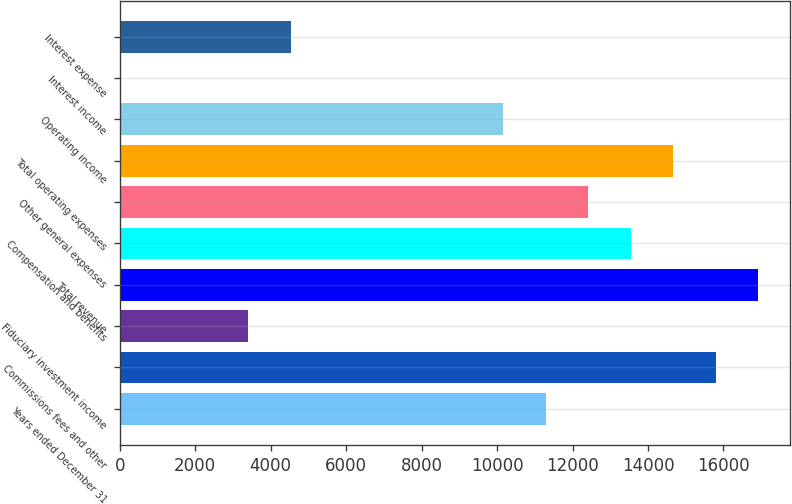<chart> <loc_0><loc_0><loc_500><loc_500><bar_chart><fcel>Years ended December 31<fcel>Commissions fees and other<fcel>Fiduciary investment income<fcel>Total revenue<fcel>Compensation and benefits<fcel>Other general expenses<fcel>Total operating expenses<fcel>Operating income<fcel>Interest income<fcel>Interest expense<nl><fcel>11287<fcel>15794.6<fcel>3398.7<fcel>16921.5<fcel>13540.8<fcel>12413.9<fcel>14667.7<fcel>10160.1<fcel>18<fcel>4525.6<nl></chart> 